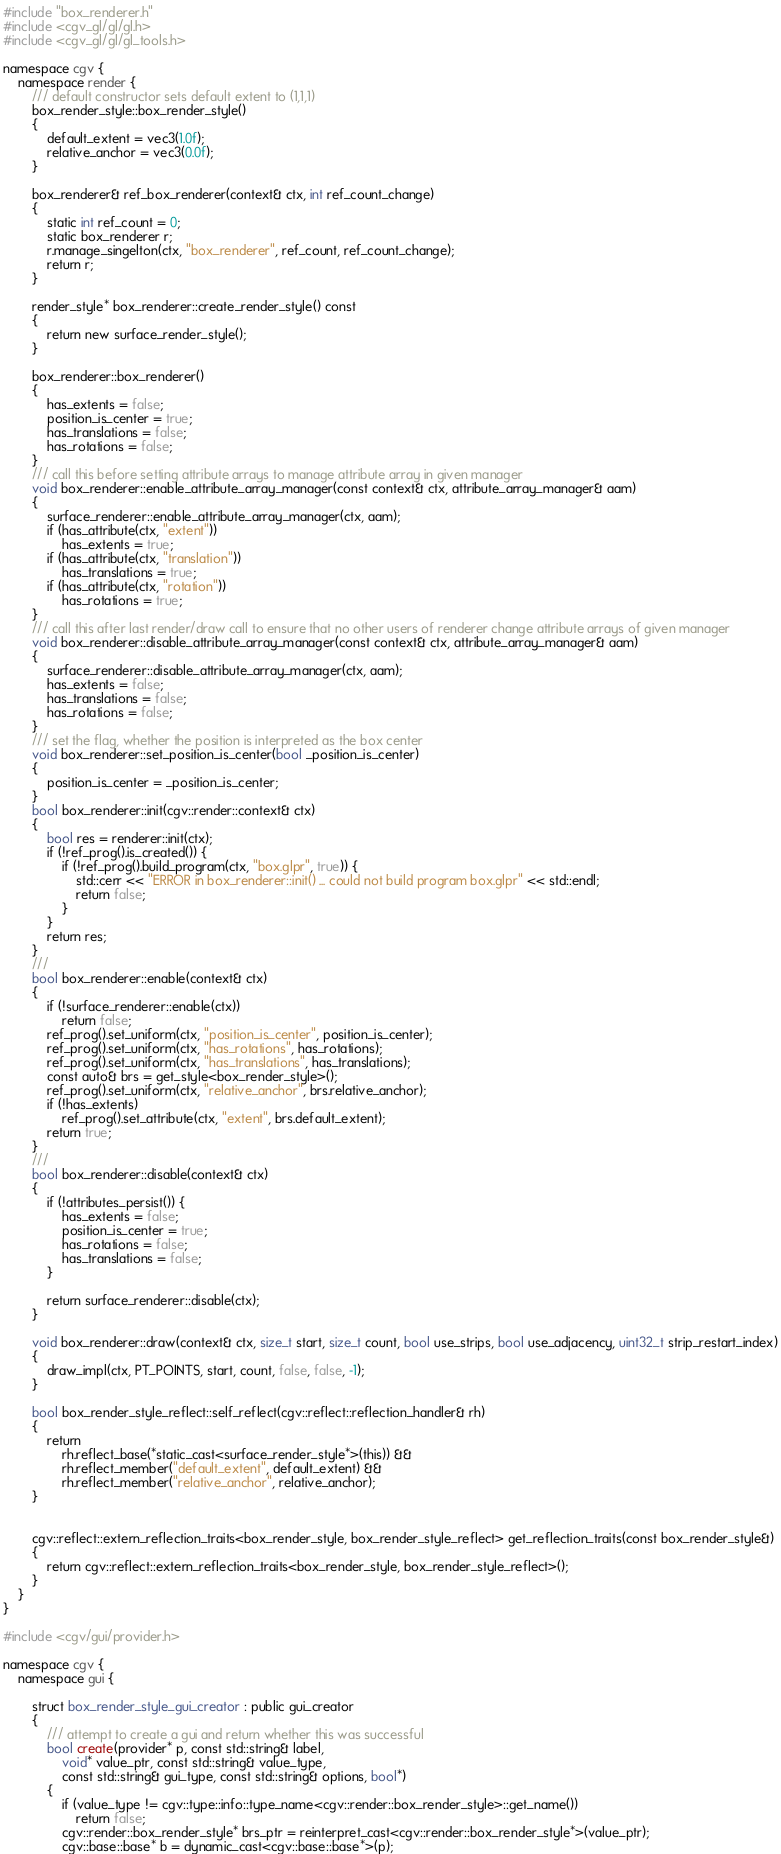<code> <loc_0><loc_0><loc_500><loc_500><_C++_>#include "box_renderer.h"
#include <cgv_gl/gl/gl.h>
#include <cgv_gl/gl/gl_tools.h>

namespace cgv {
	namespace render {
		/// default constructor sets default extent to (1,1,1)
		box_render_style::box_render_style()
		{
			default_extent = vec3(1.0f);
			relative_anchor = vec3(0.0f);
		}

		box_renderer& ref_box_renderer(context& ctx, int ref_count_change)
		{
			static int ref_count = 0;
			static box_renderer r;
			r.manage_singelton(ctx, "box_renderer", ref_count, ref_count_change);
			return r;
		}

		render_style* box_renderer::create_render_style() const
		{
			return new surface_render_style();
		}

		box_renderer::box_renderer()
		{
			has_extents = false;
			position_is_center = true;
			has_translations = false;
			has_rotations = false;
		}
		/// call this before setting attribute arrays to manage attribute array in given manager
		void box_renderer::enable_attribute_array_manager(const context& ctx, attribute_array_manager& aam)
		{
			surface_renderer::enable_attribute_array_manager(ctx, aam);
			if (has_attribute(ctx, "extent"))
				has_extents = true;
			if (has_attribute(ctx, "translation"))
				has_translations = true;
			if (has_attribute(ctx, "rotation"))
				has_rotations = true;
		}
		/// call this after last render/draw call to ensure that no other users of renderer change attribute arrays of given manager
		void box_renderer::disable_attribute_array_manager(const context& ctx, attribute_array_manager& aam)
		{
			surface_renderer::disable_attribute_array_manager(ctx, aam);
			has_extents = false;
			has_translations = false;
			has_rotations = false;
		}
		/// set the flag, whether the position is interpreted as the box center
		void box_renderer::set_position_is_center(bool _position_is_center)
		{
			position_is_center = _position_is_center;
		}
		bool box_renderer::init(cgv::render::context& ctx)
		{
			bool res = renderer::init(ctx);
			if (!ref_prog().is_created()) {
				if (!ref_prog().build_program(ctx, "box.glpr", true)) {
					std::cerr << "ERROR in box_renderer::init() ... could not build program box.glpr" << std::endl;
					return false;
				}
			}
			return res;
		}
		/// 
		bool box_renderer::enable(context& ctx)
		{
			if (!surface_renderer::enable(ctx))
				return false;
			ref_prog().set_uniform(ctx, "position_is_center", position_is_center);
			ref_prog().set_uniform(ctx, "has_rotations", has_rotations);
			ref_prog().set_uniform(ctx, "has_translations", has_translations);
			const auto& brs = get_style<box_render_style>();
			ref_prog().set_uniform(ctx, "relative_anchor", brs.relative_anchor);
			if (!has_extents)
				ref_prog().set_attribute(ctx, "extent", brs.default_extent);
			return true;
		}
		///
		bool box_renderer::disable(context& ctx)
		{
			if (!attributes_persist()) {
				has_extents = false;
				position_is_center = true;
				has_rotations = false;
				has_translations = false;
			}

			return surface_renderer::disable(ctx);
		}

		void box_renderer::draw(context& ctx, size_t start, size_t count, bool use_strips, bool use_adjacency, uint32_t strip_restart_index)
		{
			draw_impl(ctx, PT_POINTS, start, count, false, false, -1);
		}

		bool box_render_style_reflect::self_reflect(cgv::reflect::reflection_handler& rh)
		{
			return
				rh.reflect_base(*static_cast<surface_render_style*>(this)) &&
				rh.reflect_member("default_extent", default_extent) &&
				rh.reflect_member("relative_anchor", relative_anchor);
		}


		cgv::reflect::extern_reflection_traits<box_render_style, box_render_style_reflect> get_reflection_traits(const box_render_style&)
		{
			return cgv::reflect::extern_reflection_traits<box_render_style, box_render_style_reflect>();
		}
	}
}

#include <cgv/gui/provider.h>

namespace cgv {
	namespace gui {

		struct box_render_style_gui_creator : public gui_creator
		{
			/// attempt to create a gui and return whether this was successful
			bool create(provider* p, const std::string& label,
				void* value_ptr, const std::string& value_type,
				const std::string& gui_type, const std::string& options, bool*)
			{
				if (value_type != cgv::type::info::type_name<cgv::render::box_render_style>::get_name())
					return false;
				cgv::render::box_render_style* brs_ptr = reinterpret_cast<cgv::render::box_render_style*>(value_ptr);
				cgv::base::base* b = dynamic_cast<cgv::base::base*>(p);</code> 